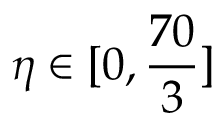<formula> <loc_0><loc_0><loc_500><loc_500>\eta \in [ 0 , \frac { 7 0 } { 3 } ]</formula> 